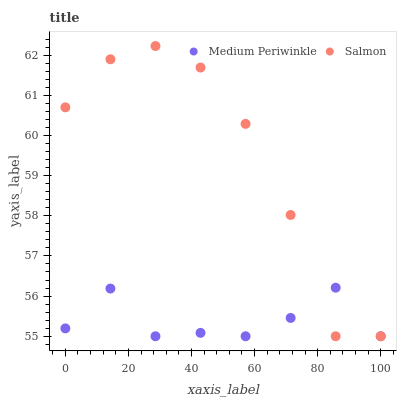Does Medium Periwinkle have the minimum area under the curve?
Answer yes or no. Yes. Does Salmon have the maximum area under the curve?
Answer yes or no. Yes. Does Medium Periwinkle have the maximum area under the curve?
Answer yes or no. No. Is Medium Periwinkle the smoothest?
Answer yes or no. Yes. Is Salmon the roughest?
Answer yes or no. Yes. Is Medium Periwinkle the roughest?
Answer yes or no. No. Does Salmon have the lowest value?
Answer yes or no. Yes. Does Salmon have the highest value?
Answer yes or no. Yes. Does Medium Periwinkle have the highest value?
Answer yes or no. No. Does Medium Periwinkle intersect Salmon?
Answer yes or no. Yes. Is Medium Periwinkle less than Salmon?
Answer yes or no. No. Is Medium Periwinkle greater than Salmon?
Answer yes or no. No. 